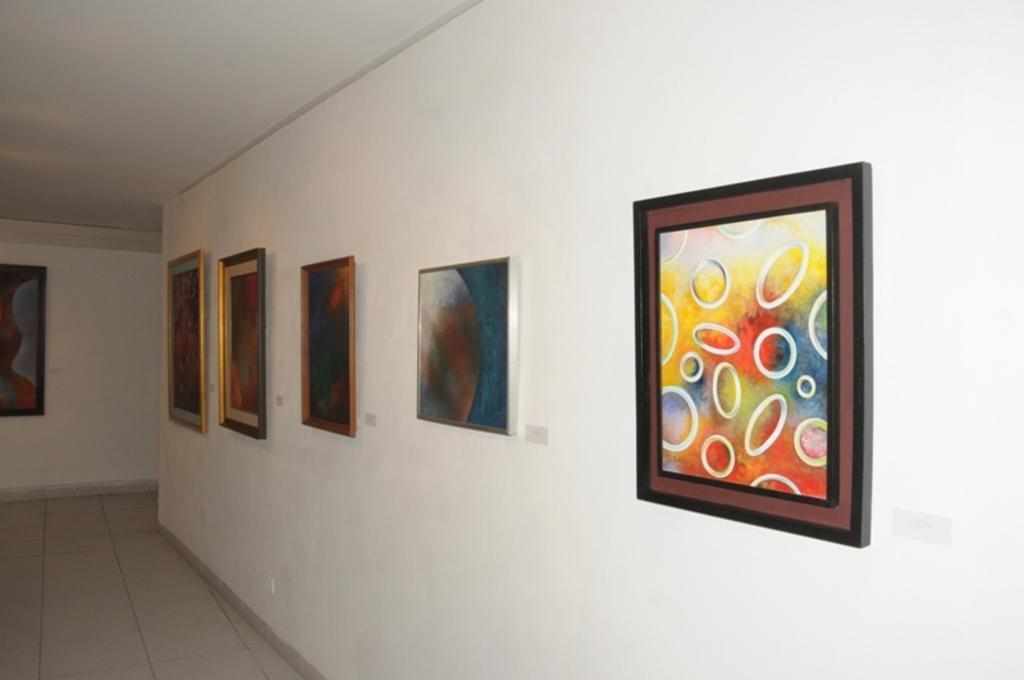Can you describe this image briefly? In this image there are frames on the wall. 